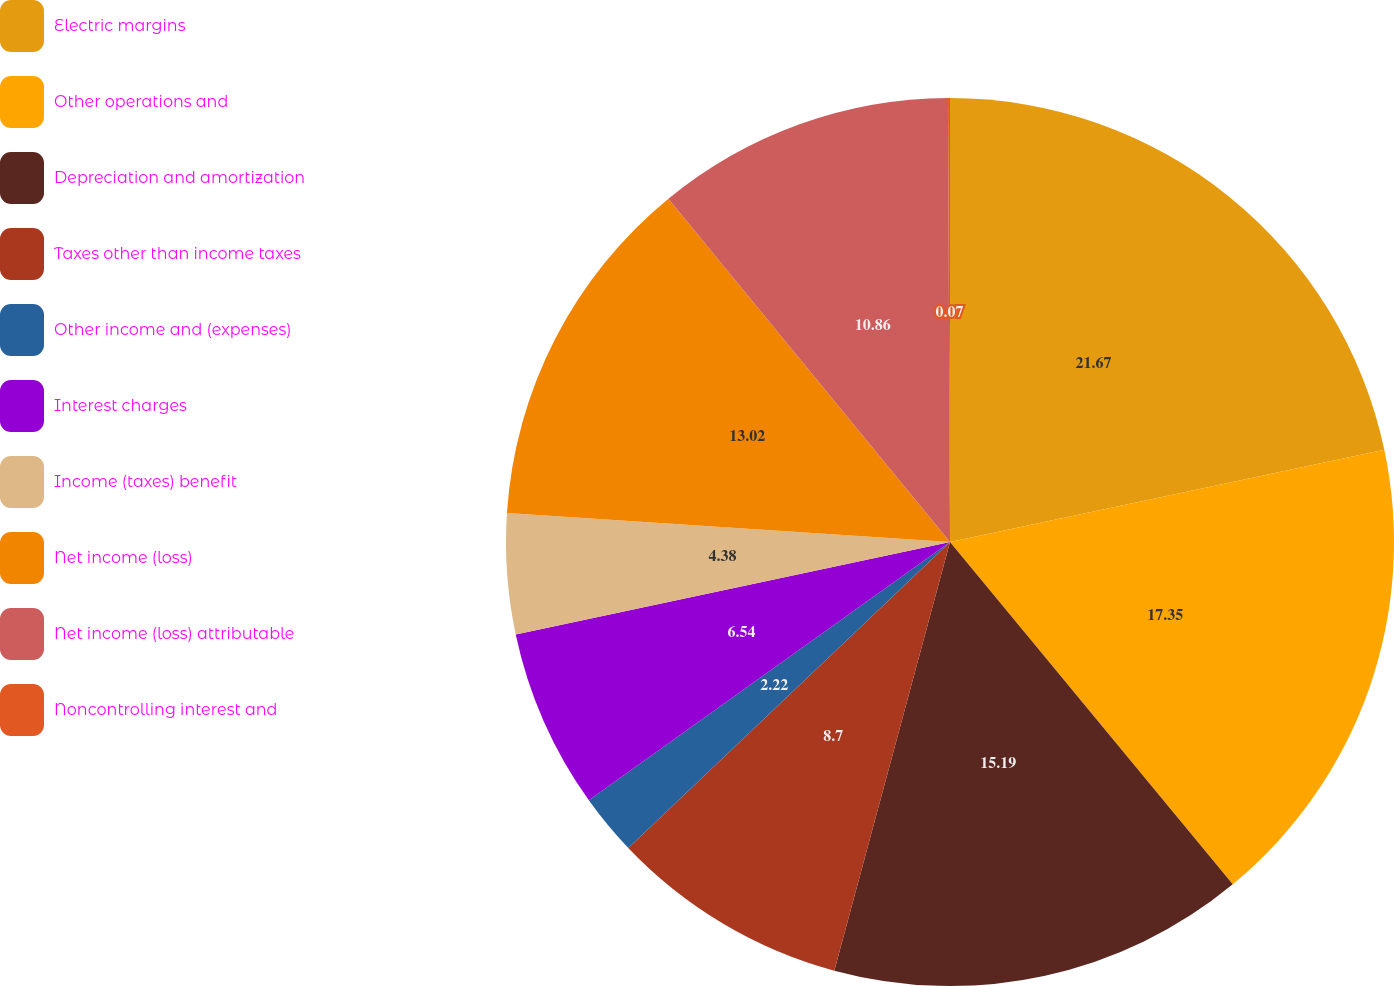<chart> <loc_0><loc_0><loc_500><loc_500><pie_chart><fcel>Electric margins<fcel>Other operations and<fcel>Depreciation and amortization<fcel>Taxes other than income taxes<fcel>Other income and (expenses)<fcel>Interest charges<fcel>Income (taxes) benefit<fcel>Net income (loss)<fcel>Net income (loss) attributable<fcel>Noncontrolling interest and<nl><fcel>21.66%<fcel>17.34%<fcel>15.18%<fcel>8.7%<fcel>2.22%<fcel>6.54%<fcel>4.38%<fcel>13.02%<fcel>10.86%<fcel>0.07%<nl></chart> 